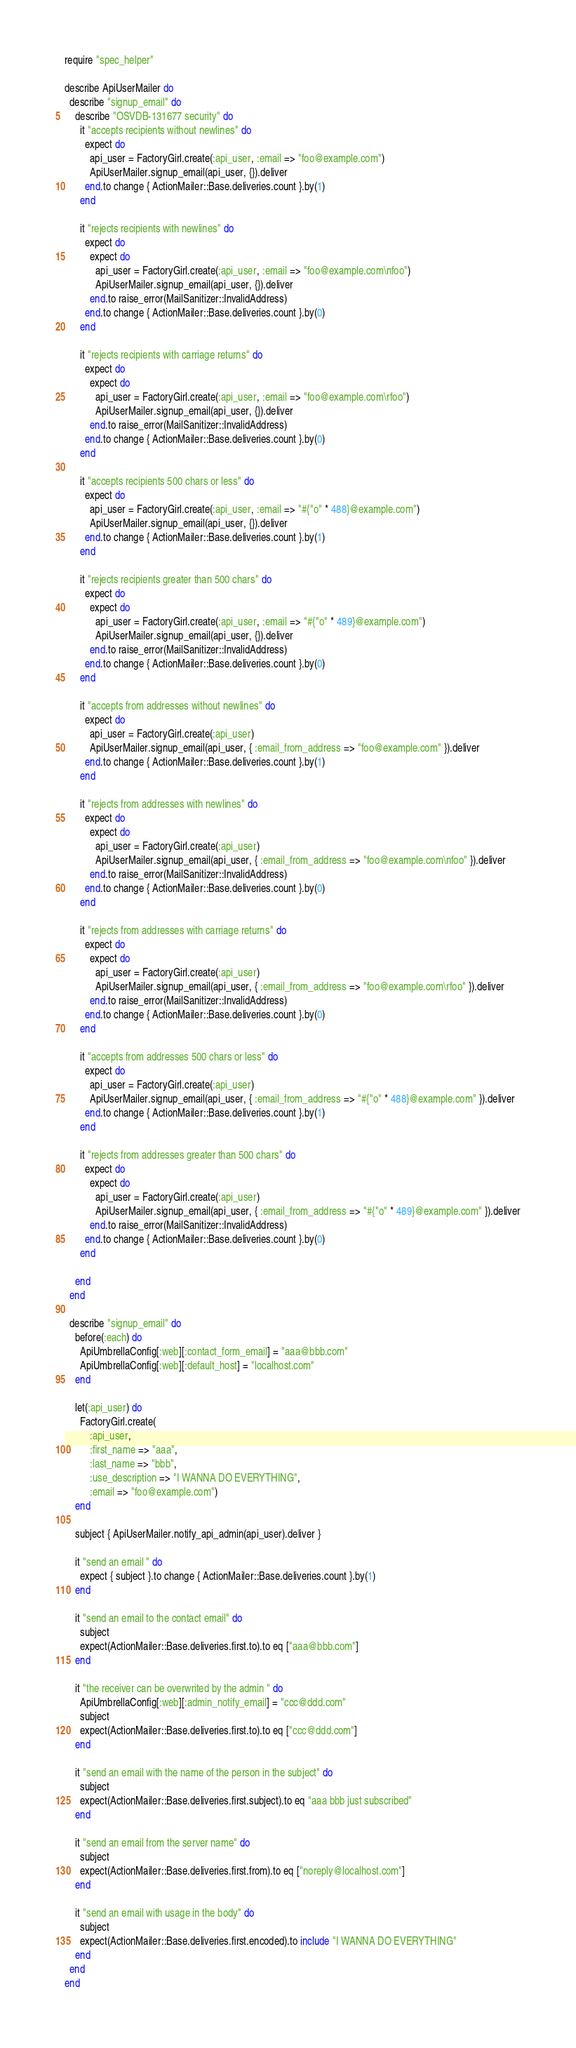Convert code to text. <code><loc_0><loc_0><loc_500><loc_500><_Ruby_>require "spec_helper"

describe ApiUserMailer do
  describe "signup_email" do
    describe "OSVDB-131677 security" do
      it "accepts recipients without newlines" do
        expect do
          api_user = FactoryGirl.create(:api_user, :email => "foo@example.com")
          ApiUserMailer.signup_email(api_user, {}).deliver
        end.to change { ActionMailer::Base.deliveries.count }.by(1)
      end

      it "rejects recipients with newlines" do
        expect do
          expect do
            api_user = FactoryGirl.create(:api_user, :email => "foo@example.com\nfoo")
            ApiUserMailer.signup_email(api_user, {}).deliver
          end.to raise_error(MailSanitizer::InvalidAddress)
        end.to change { ActionMailer::Base.deliveries.count }.by(0)
      end

      it "rejects recipients with carriage returns" do
        expect do
          expect do
            api_user = FactoryGirl.create(:api_user, :email => "foo@example.com\rfoo")
            ApiUserMailer.signup_email(api_user, {}).deliver
          end.to raise_error(MailSanitizer::InvalidAddress)
        end.to change { ActionMailer::Base.deliveries.count }.by(0)
      end

      it "accepts recipients 500 chars or less" do
        expect do
          api_user = FactoryGirl.create(:api_user, :email => "#{"o" * 488}@example.com")
          ApiUserMailer.signup_email(api_user, {}).deliver
        end.to change { ActionMailer::Base.deliveries.count }.by(1)
      end

      it "rejects recipients greater than 500 chars" do
        expect do
          expect do
            api_user = FactoryGirl.create(:api_user, :email => "#{"o" * 489}@example.com")
            ApiUserMailer.signup_email(api_user, {}).deliver
          end.to raise_error(MailSanitizer::InvalidAddress)
        end.to change { ActionMailer::Base.deliveries.count }.by(0)
      end

      it "accepts from addresses without newlines" do
        expect do
          api_user = FactoryGirl.create(:api_user)
          ApiUserMailer.signup_email(api_user, { :email_from_address => "foo@example.com" }).deliver
        end.to change { ActionMailer::Base.deliveries.count }.by(1)
      end

      it "rejects from addresses with newlines" do
        expect do
          expect do
            api_user = FactoryGirl.create(:api_user)
            ApiUserMailer.signup_email(api_user, { :email_from_address => "foo@example.com\nfoo" }).deliver
          end.to raise_error(MailSanitizer::InvalidAddress)
        end.to change { ActionMailer::Base.deliveries.count }.by(0)
      end

      it "rejects from addresses with carriage returns" do
        expect do
          expect do
            api_user = FactoryGirl.create(:api_user)
            ApiUserMailer.signup_email(api_user, { :email_from_address => "foo@example.com\rfoo" }).deliver
          end.to raise_error(MailSanitizer::InvalidAddress)
        end.to change { ActionMailer::Base.deliveries.count }.by(0)
      end

      it "accepts from addresses 500 chars or less" do
        expect do
          api_user = FactoryGirl.create(:api_user)
          ApiUserMailer.signup_email(api_user, { :email_from_address => "#{"o" * 488}@example.com" }).deliver
        end.to change { ActionMailer::Base.deliveries.count }.by(1)
      end

      it "rejects from addresses greater than 500 chars" do
        expect do
          expect do
            api_user = FactoryGirl.create(:api_user)
            ApiUserMailer.signup_email(api_user, { :email_from_address => "#{"o" * 489}@example.com" }).deliver
          end.to raise_error(MailSanitizer::InvalidAddress)
        end.to change { ActionMailer::Base.deliveries.count }.by(0)
      end

    end
  end

  describe "signup_email" do
    before(:each) do
      ApiUmbrellaConfig[:web][:contact_form_email] = "aaa@bbb.com"
      ApiUmbrellaConfig[:web][:default_host] = "localhost.com"
    end

    let(:api_user) do
      FactoryGirl.create(
          :api_user,
          :first_name => "aaa",
          :last_name => "bbb",
          :use_description => "I WANNA DO EVERYTHING",
          :email => "foo@example.com")
    end

    subject { ApiUserMailer.notify_api_admin(api_user).deliver }

    it "send an email " do
      expect { subject }.to change { ActionMailer::Base.deliveries.count }.by(1)
    end

    it "send an email to the contact email" do
      subject
      expect(ActionMailer::Base.deliveries.first.to).to eq ["aaa@bbb.com"]
    end

    it "the receiver can be overwrited by the admin " do
      ApiUmbrellaConfig[:web][:admin_notify_email] = "ccc@ddd.com"
      subject
      expect(ActionMailer::Base.deliveries.first.to).to eq ["ccc@ddd.com"]
    end

    it "send an email with the name of the person in the subject" do
      subject
      expect(ActionMailer::Base.deliveries.first.subject).to eq "aaa bbb just subscribed"
    end

    it "send an email from the server name" do
      subject
      expect(ActionMailer::Base.deliveries.first.from).to eq ["noreply@localhost.com"]
    end

    it "send an email with usage in the body" do
      subject
      expect(ActionMailer::Base.deliveries.first.encoded).to include "I WANNA DO EVERYTHING"
    end
  end
end
</code> 